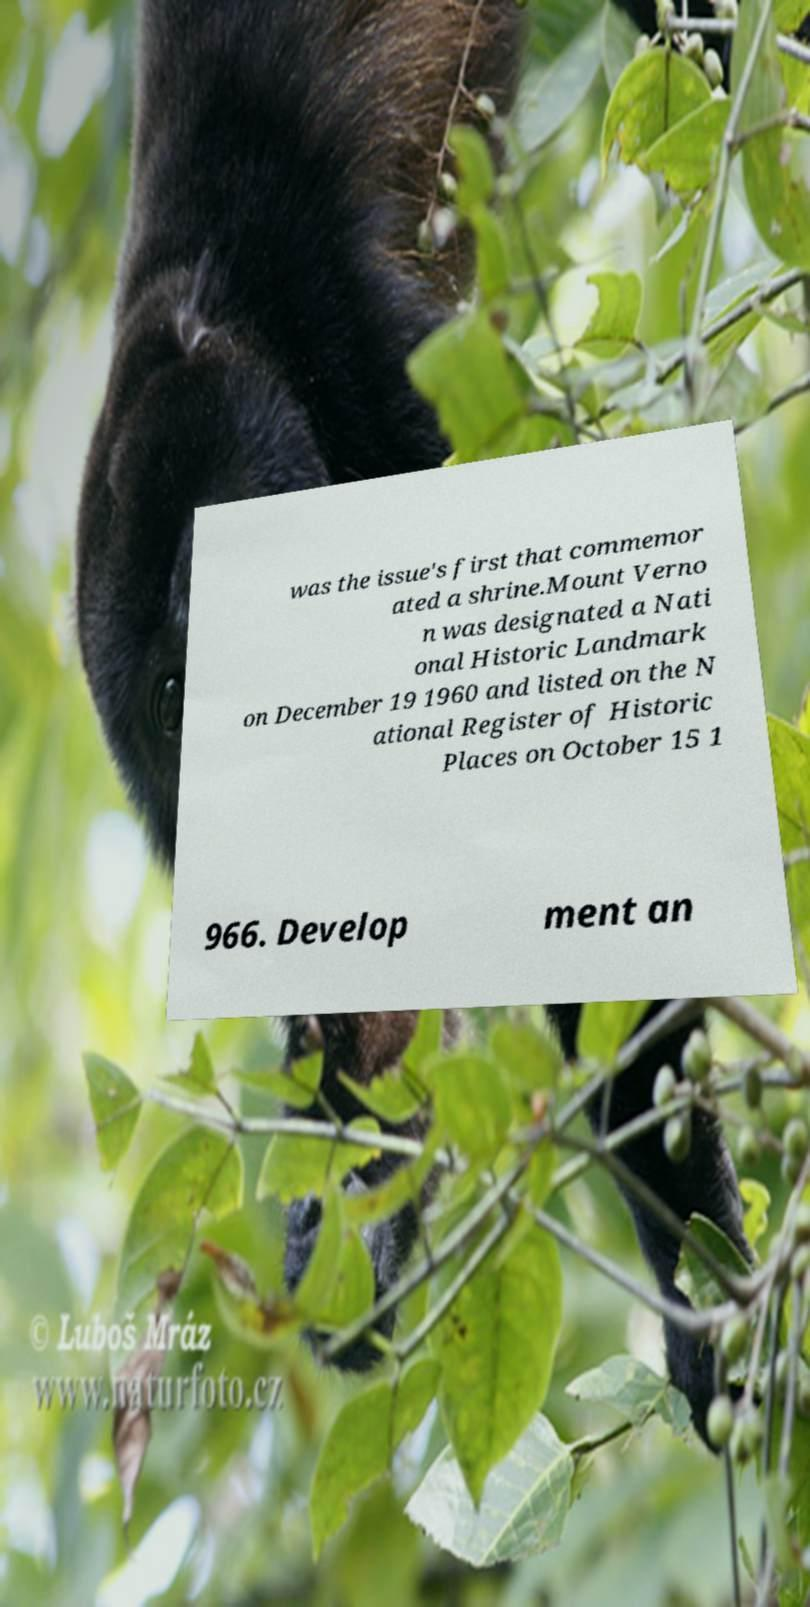There's text embedded in this image that I need extracted. Can you transcribe it verbatim? was the issue's first that commemor ated a shrine.Mount Verno n was designated a Nati onal Historic Landmark on December 19 1960 and listed on the N ational Register of Historic Places on October 15 1 966. Develop ment an 